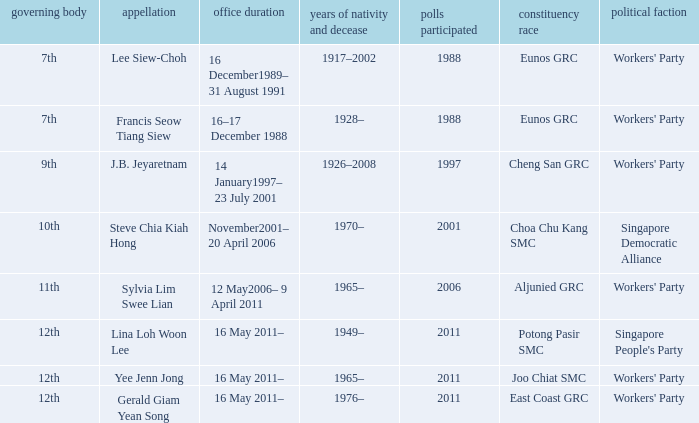What number parliament held it's election in 1997? 9th. 